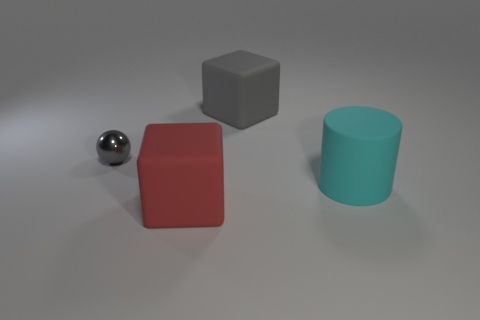How many metal balls are the same size as the gray cube?
Your response must be concise. 0. How many large things are in front of the big block left of the large block on the right side of the large red object?
Offer a terse response. 0. Are there an equal number of red blocks that are in front of the big red rubber thing and gray rubber blocks that are on the left side of the metal thing?
Offer a terse response. Yes. How many other shiny things are the same shape as the small gray metal thing?
Keep it short and to the point. 0. Is there a small yellow cube that has the same material as the small gray thing?
Offer a very short reply. No. The matte thing that is the same color as the metallic object is what shape?
Provide a succinct answer. Cube. How many tiny brown metallic cubes are there?
Offer a very short reply. 0. How many blocks are big blue rubber objects or large gray things?
Make the answer very short. 1. The cylinder that is the same size as the gray rubber thing is what color?
Offer a very short reply. Cyan. What number of things are left of the gray matte thing and on the right side of the small shiny sphere?
Your answer should be very brief. 1. 